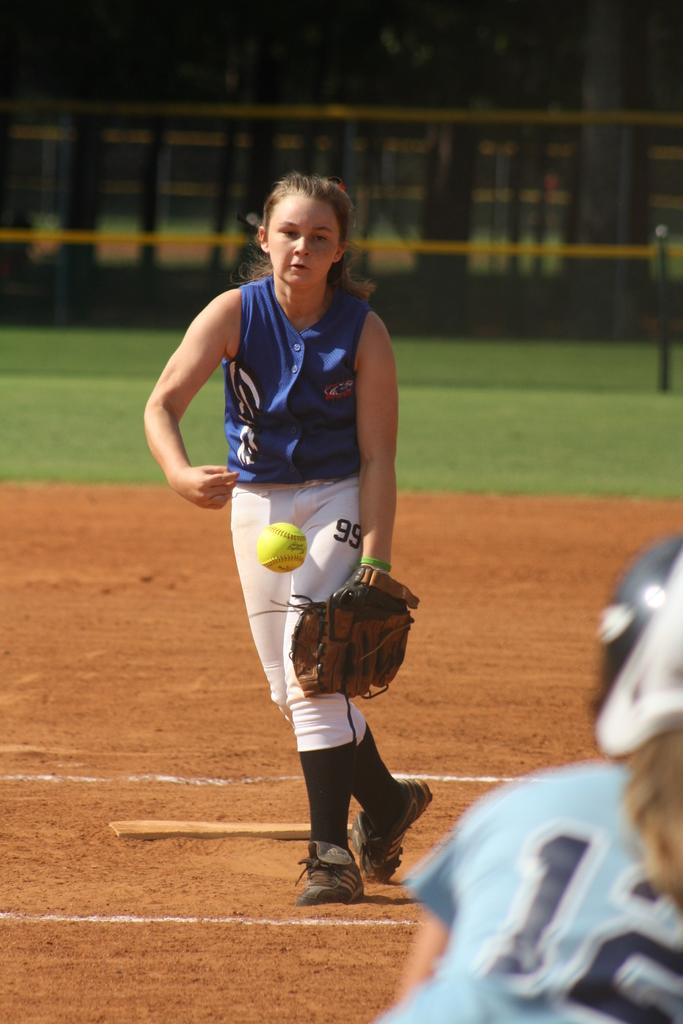Who is the main subject in the image? There is a woman in the image. What is the woman doing in the image? The woman is playing baseball. What type of clothing is the woman wearing on her upper body? The woman is wearing a t-shirt. What color are the trousers the woman is wearing? The woman is wearing white color trousers. Can you spot the shirt that the woman is wearing in the image? The woman is not wearing a shirt; she is wearing a t-shirt, as mentioned in the facts. 